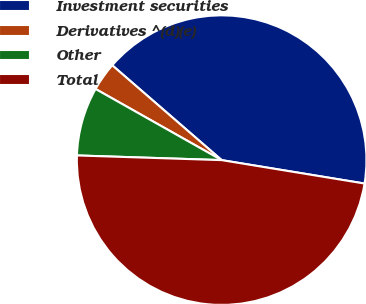Convert chart. <chart><loc_0><loc_0><loc_500><loc_500><pie_chart><fcel>Investment securities<fcel>Derivatives ^(d)(e)<fcel>Other<fcel>Total<nl><fcel>41.22%<fcel>3.19%<fcel>7.66%<fcel>47.93%<nl></chart> 